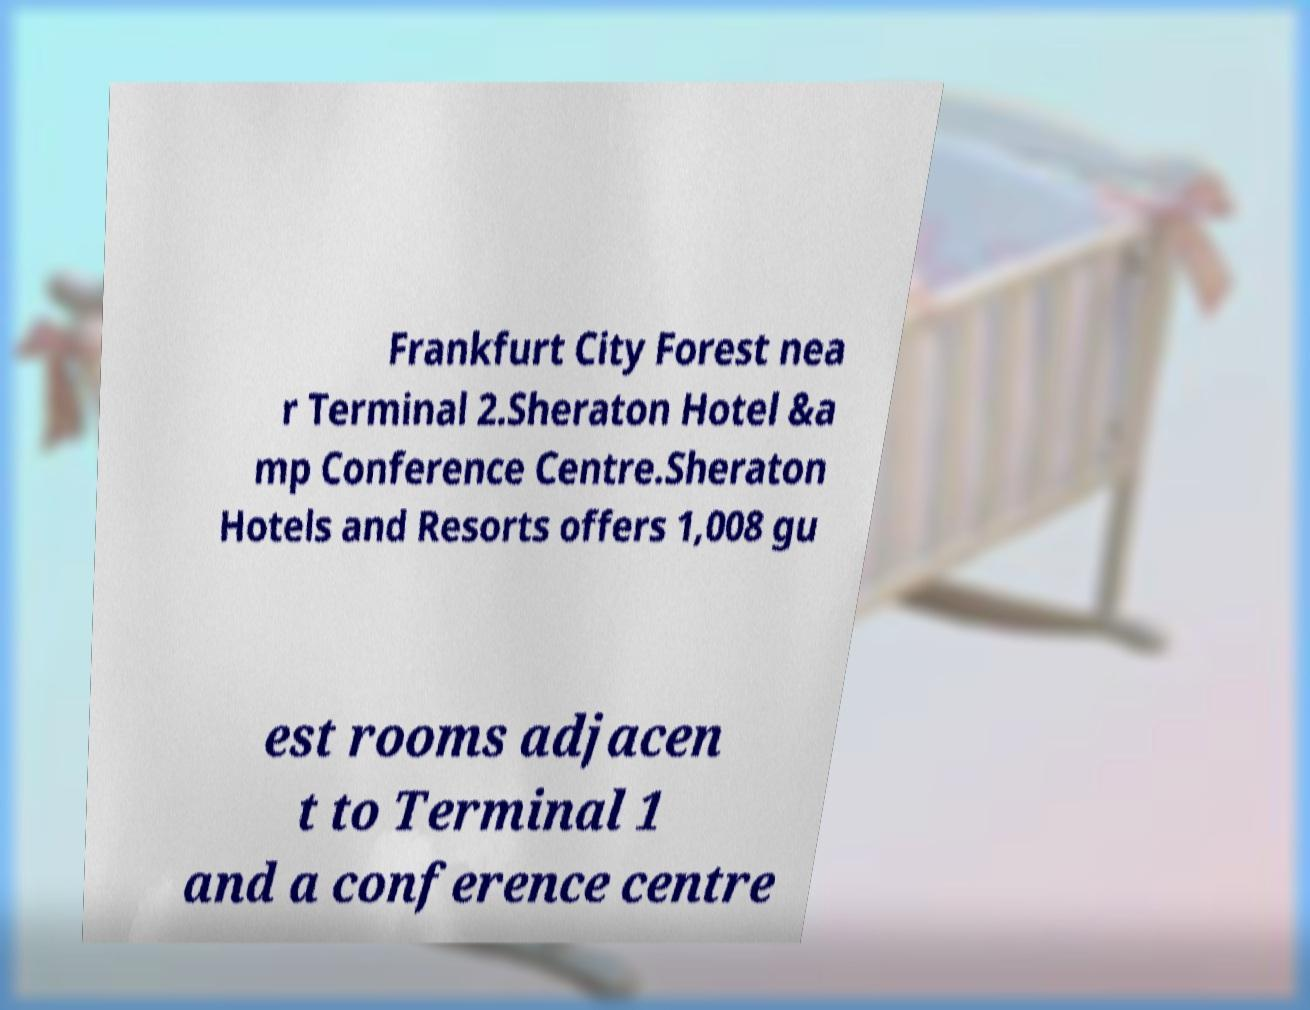Could you extract and type out the text from this image? Frankfurt City Forest nea r Terminal 2.Sheraton Hotel &a mp Conference Centre.Sheraton Hotels and Resorts offers 1,008 gu est rooms adjacen t to Terminal 1 and a conference centre 